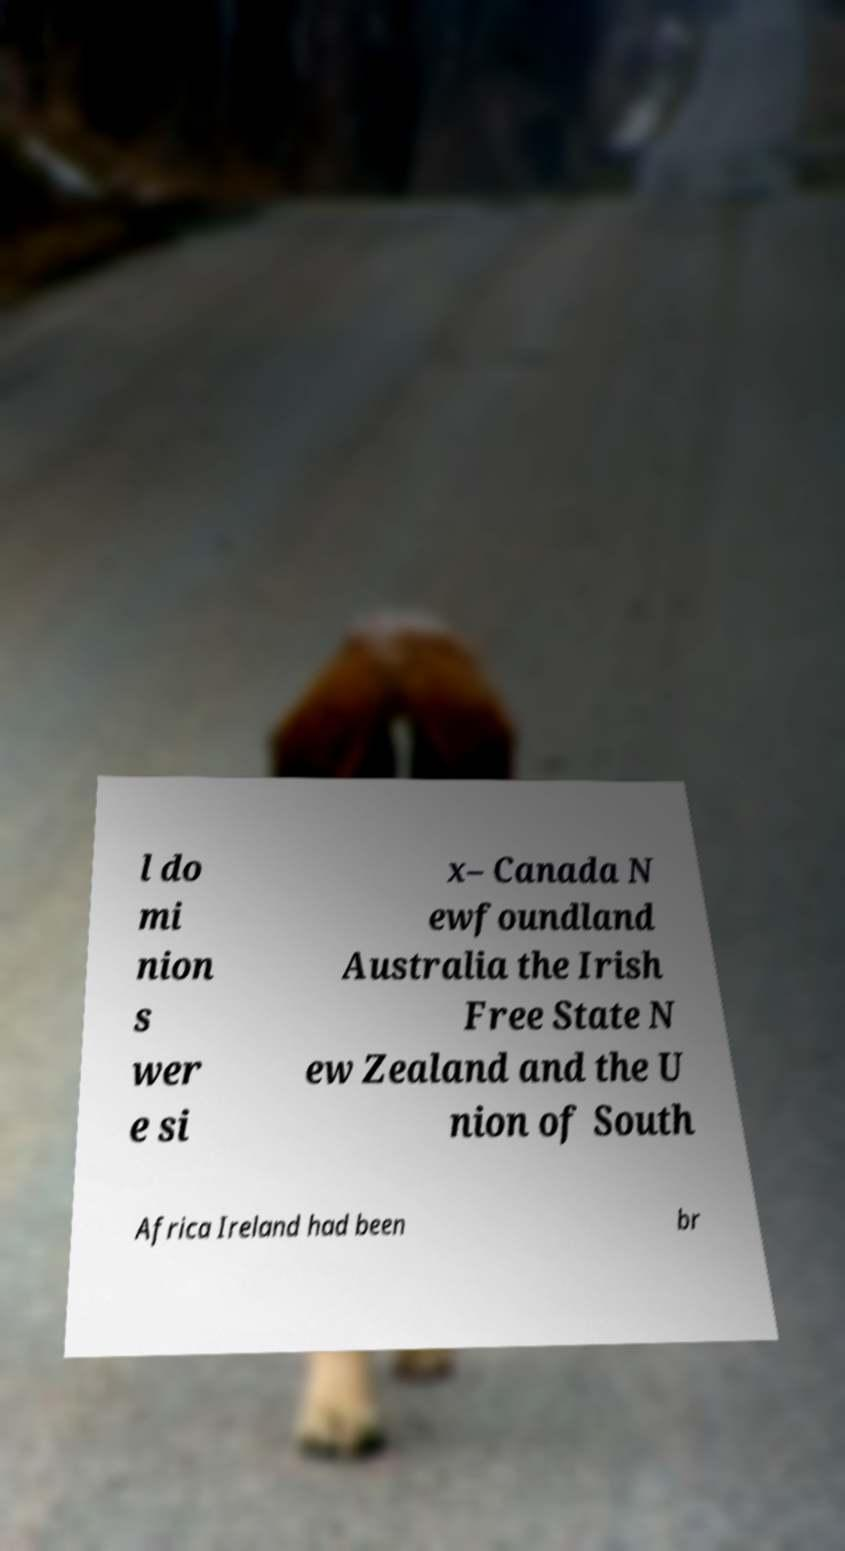Can you read and provide the text displayed in the image?This photo seems to have some interesting text. Can you extract and type it out for me? l do mi nion s wer e si x– Canada N ewfoundland Australia the Irish Free State N ew Zealand and the U nion of South Africa Ireland had been br 